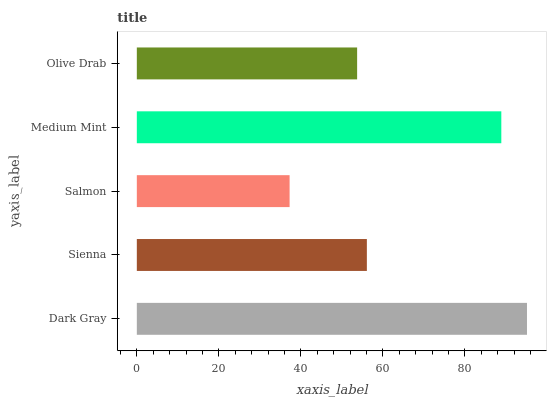Is Salmon the minimum?
Answer yes or no. Yes. Is Dark Gray the maximum?
Answer yes or no. Yes. Is Sienna the minimum?
Answer yes or no. No. Is Sienna the maximum?
Answer yes or no. No. Is Dark Gray greater than Sienna?
Answer yes or no. Yes. Is Sienna less than Dark Gray?
Answer yes or no. Yes. Is Sienna greater than Dark Gray?
Answer yes or no. No. Is Dark Gray less than Sienna?
Answer yes or no. No. Is Sienna the high median?
Answer yes or no. Yes. Is Sienna the low median?
Answer yes or no. Yes. Is Medium Mint the high median?
Answer yes or no. No. Is Dark Gray the low median?
Answer yes or no. No. 